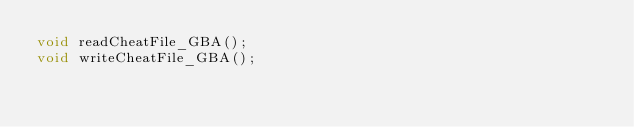<code> <loc_0><loc_0><loc_500><loc_500><_C++_>void readCheatFile_GBA();
void writeCheatFile_GBA();
</code> 